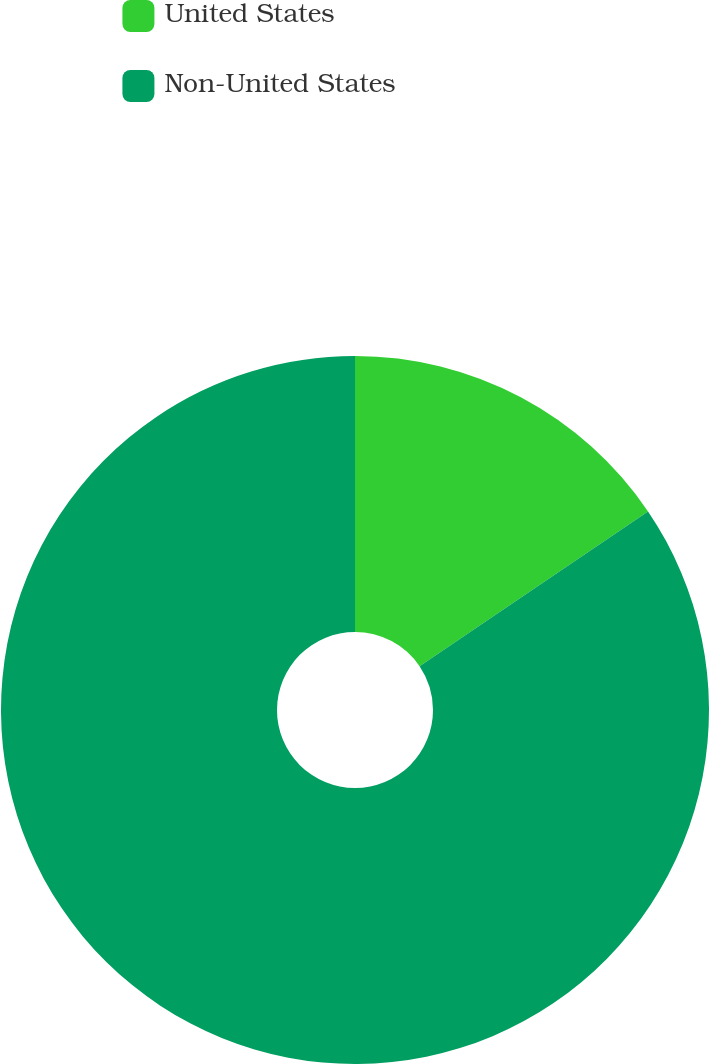Convert chart. <chart><loc_0><loc_0><loc_500><loc_500><pie_chart><fcel>United States<fcel>Non-United States<nl><fcel>15.52%<fcel>84.48%<nl></chart> 